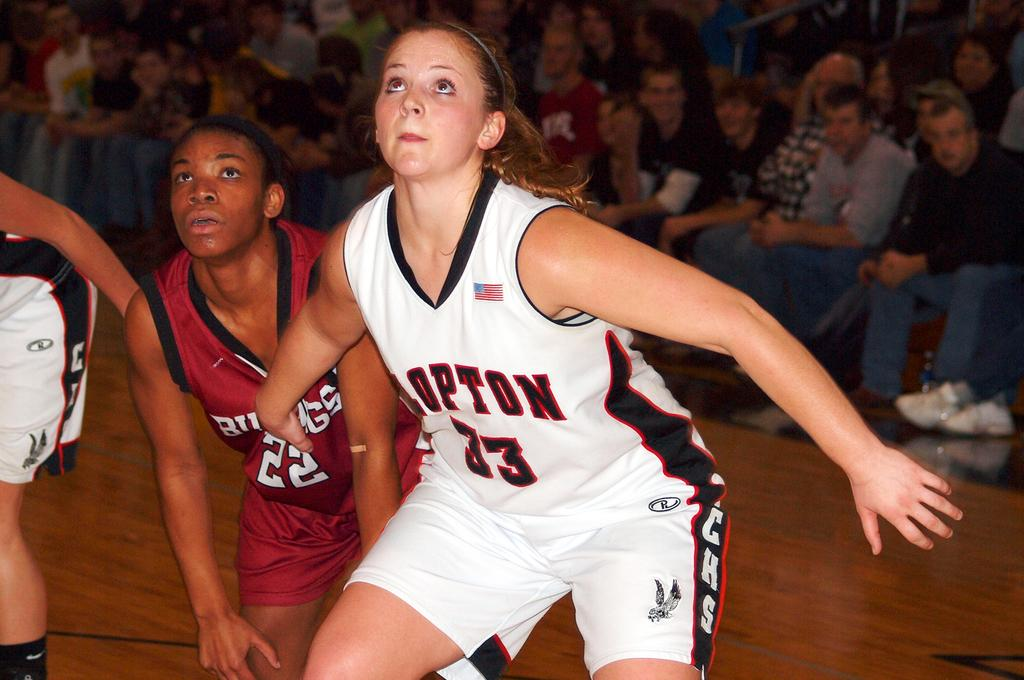<image>
Describe the image concisely. A female basketball player with the number 33 on her mid section. 